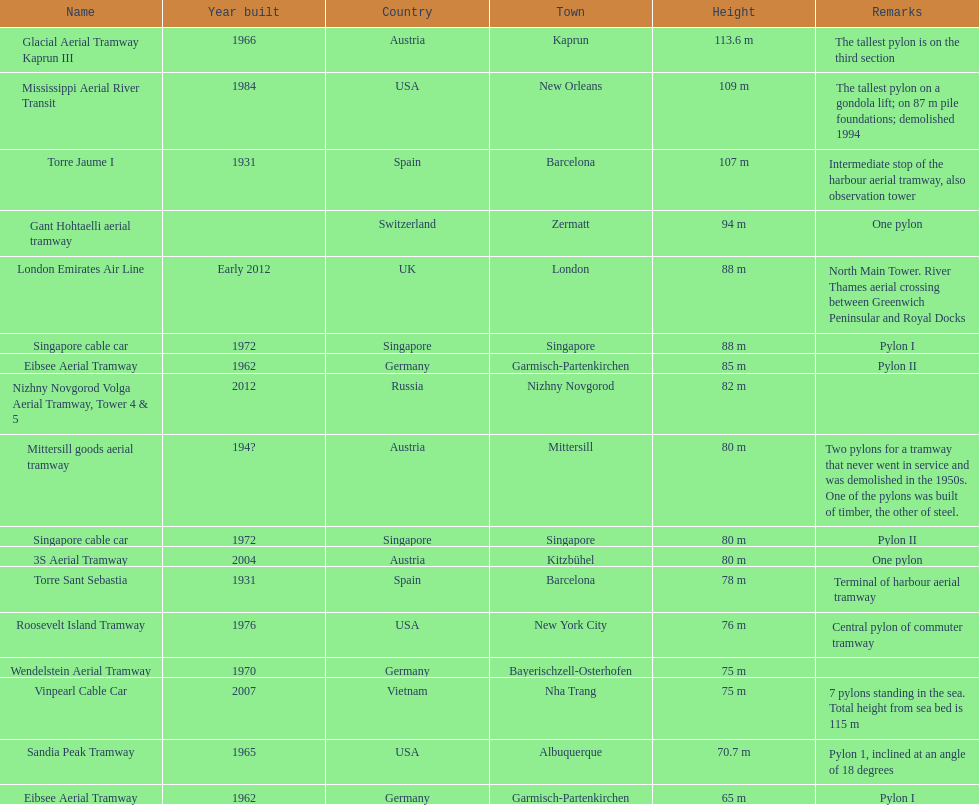Which pylon is the least tall? Eibsee Aerial Tramway. 